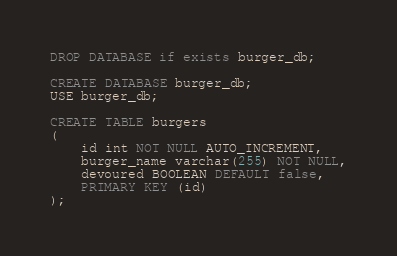<code> <loc_0><loc_0><loc_500><loc_500><_SQL_>DROP DATABASE if exists burger_db;

CREATE DATABASE burger_db;
USE burger_db;

CREATE TABLE burgers
(
	id int NOT NULL AUTO_INCREMENT,
	burger_name varchar(255) NOT NULL,
	devoured BOOLEAN DEFAULT false,
	PRIMARY KEY (id)
);
</code> 